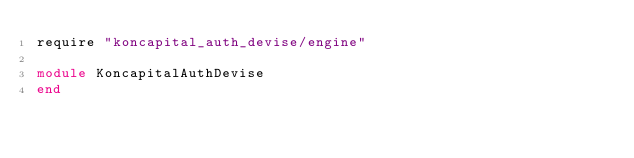<code> <loc_0><loc_0><loc_500><loc_500><_Ruby_>require "koncapital_auth_devise/engine"

module KoncapitalAuthDevise
end
</code> 